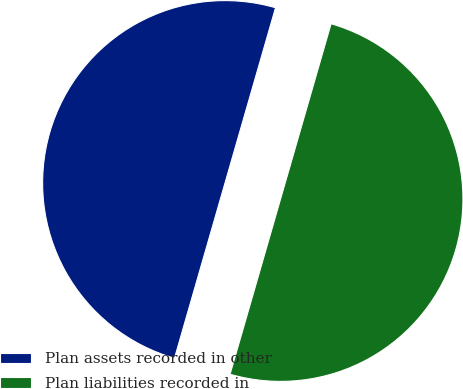Convert chart to OTSL. <chart><loc_0><loc_0><loc_500><loc_500><pie_chart><fcel>Plan assets recorded in other<fcel>Plan liabilities recorded in<nl><fcel>50.0%<fcel>50.0%<nl></chart> 